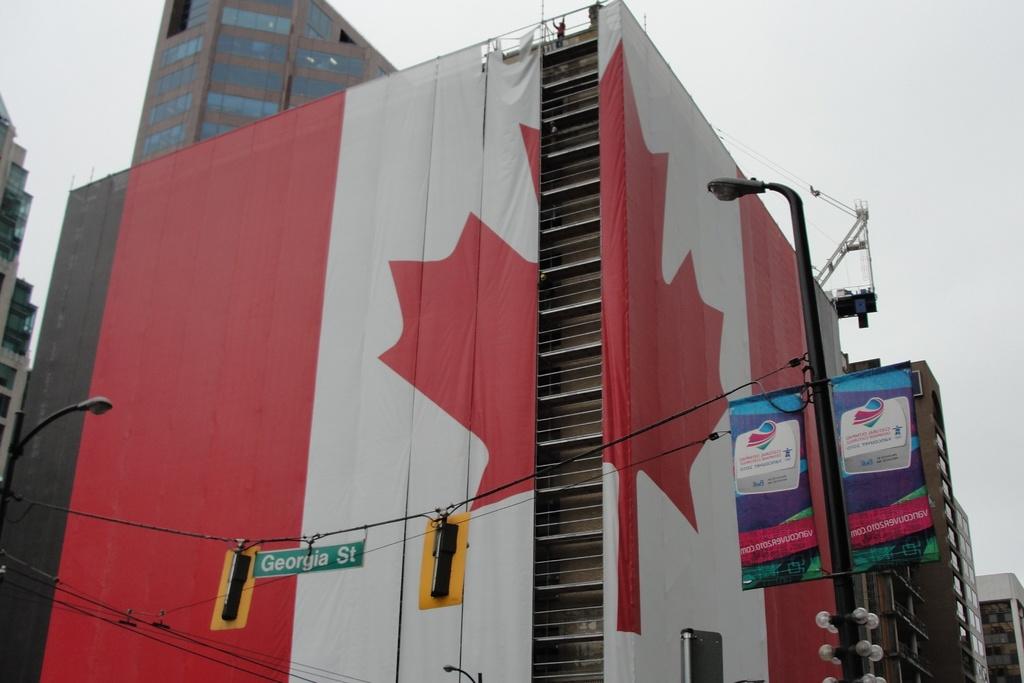What street does this building intersect?
Keep it short and to the point. Georgia st. 